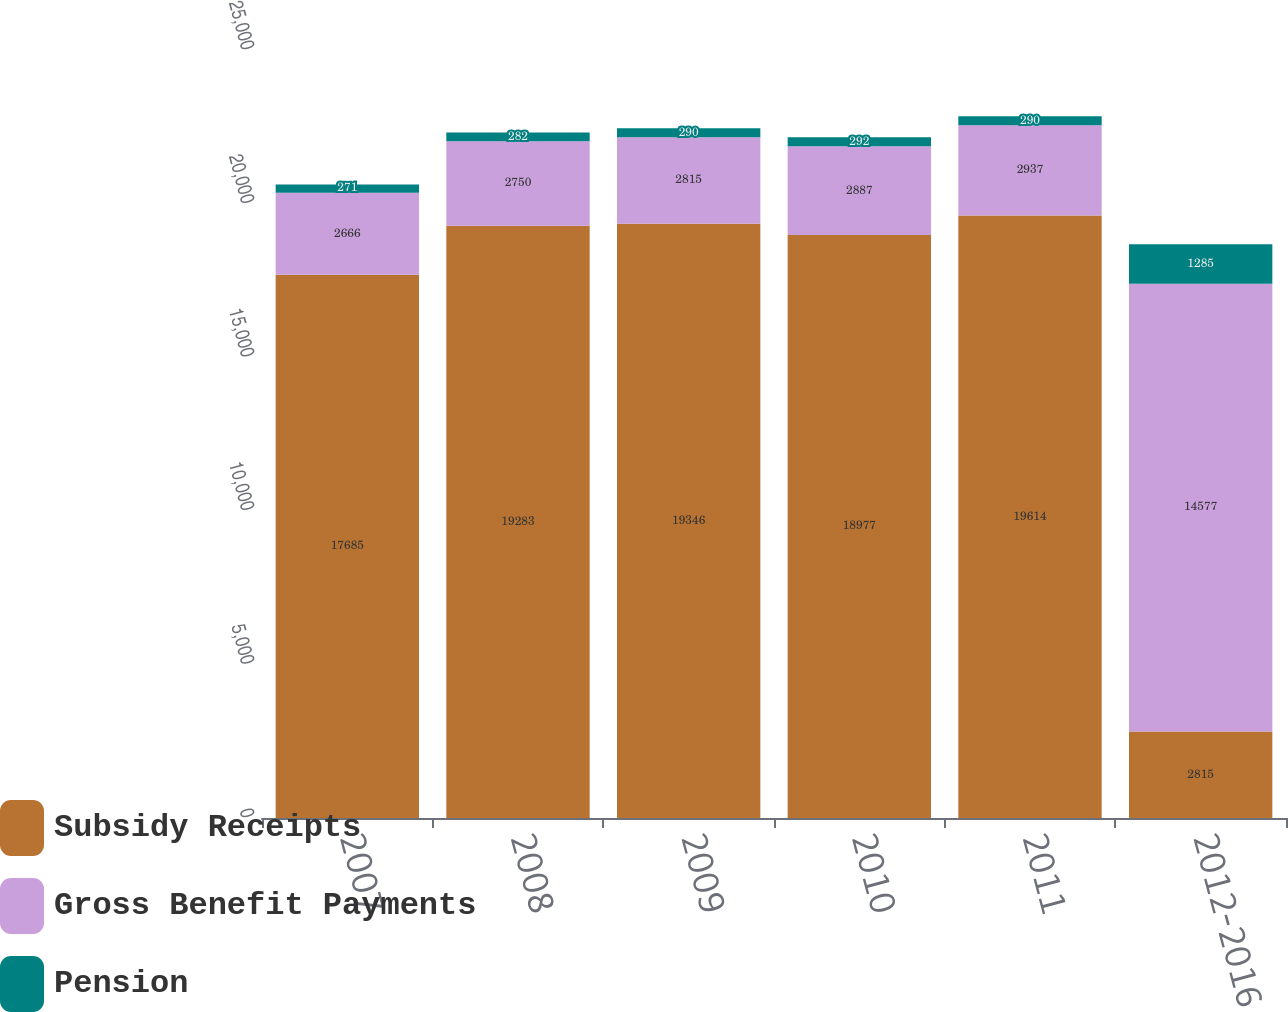Convert chart to OTSL. <chart><loc_0><loc_0><loc_500><loc_500><stacked_bar_chart><ecel><fcel>2007<fcel>2008<fcel>2009<fcel>2010<fcel>2011<fcel>2012-2016<nl><fcel>Subsidy Receipts<fcel>17685<fcel>19283<fcel>19346<fcel>18977<fcel>19614<fcel>2815<nl><fcel>Gross Benefit Payments<fcel>2666<fcel>2750<fcel>2815<fcel>2887<fcel>2937<fcel>14577<nl><fcel>Pension<fcel>271<fcel>282<fcel>290<fcel>292<fcel>290<fcel>1285<nl></chart> 